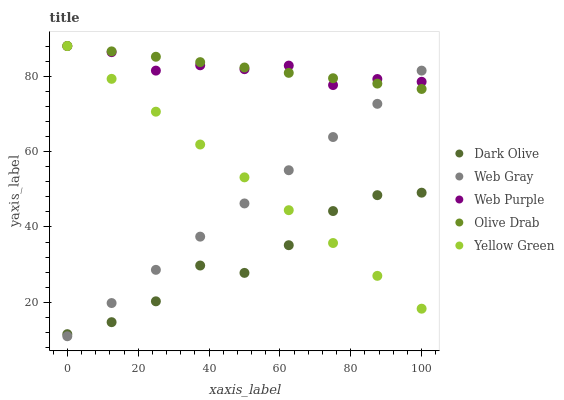Does Dark Olive have the minimum area under the curve?
Answer yes or no. Yes. Does Olive Drab have the maximum area under the curve?
Answer yes or no. Yes. Does Web Gray have the minimum area under the curve?
Answer yes or no. No. Does Web Gray have the maximum area under the curve?
Answer yes or no. No. Is Web Gray the smoothest?
Answer yes or no. Yes. Is Dark Olive the roughest?
Answer yes or no. Yes. Is Dark Olive the smoothest?
Answer yes or no. No. Is Web Gray the roughest?
Answer yes or no. No. Does Web Gray have the lowest value?
Answer yes or no. Yes. Does Dark Olive have the lowest value?
Answer yes or no. No. Does Olive Drab have the highest value?
Answer yes or no. Yes. Does Web Gray have the highest value?
Answer yes or no. No. Is Dark Olive less than Web Purple?
Answer yes or no. Yes. Is Web Purple greater than Dark Olive?
Answer yes or no. Yes. Does Web Gray intersect Yellow Green?
Answer yes or no. Yes. Is Web Gray less than Yellow Green?
Answer yes or no. No. Is Web Gray greater than Yellow Green?
Answer yes or no. No. Does Dark Olive intersect Web Purple?
Answer yes or no. No. 